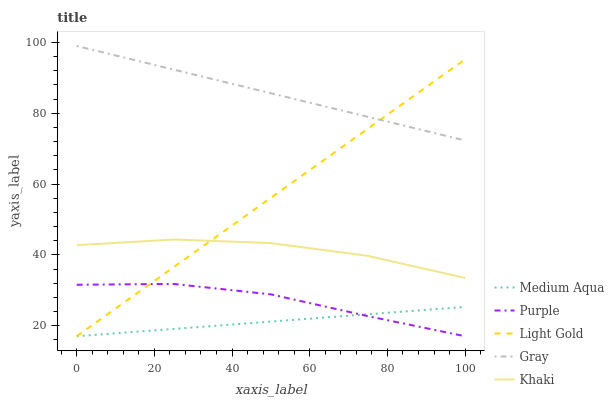Does Medium Aqua have the minimum area under the curve?
Answer yes or no. Yes. Does Gray have the maximum area under the curve?
Answer yes or no. Yes. Does Light Gold have the minimum area under the curve?
Answer yes or no. No. Does Light Gold have the maximum area under the curve?
Answer yes or no. No. Is Medium Aqua the smoothest?
Answer yes or no. Yes. Is Khaki the roughest?
Answer yes or no. Yes. Is Light Gold the smoothest?
Answer yes or no. No. Is Light Gold the roughest?
Answer yes or no. No. Does Purple have the lowest value?
Answer yes or no. Yes. Does Khaki have the lowest value?
Answer yes or no. No. Does Gray have the highest value?
Answer yes or no. Yes. Does Light Gold have the highest value?
Answer yes or no. No. Is Purple less than Khaki?
Answer yes or no. Yes. Is Khaki greater than Medium Aqua?
Answer yes or no. Yes. Does Light Gold intersect Khaki?
Answer yes or no. Yes. Is Light Gold less than Khaki?
Answer yes or no. No. Is Light Gold greater than Khaki?
Answer yes or no. No. Does Purple intersect Khaki?
Answer yes or no. No. 